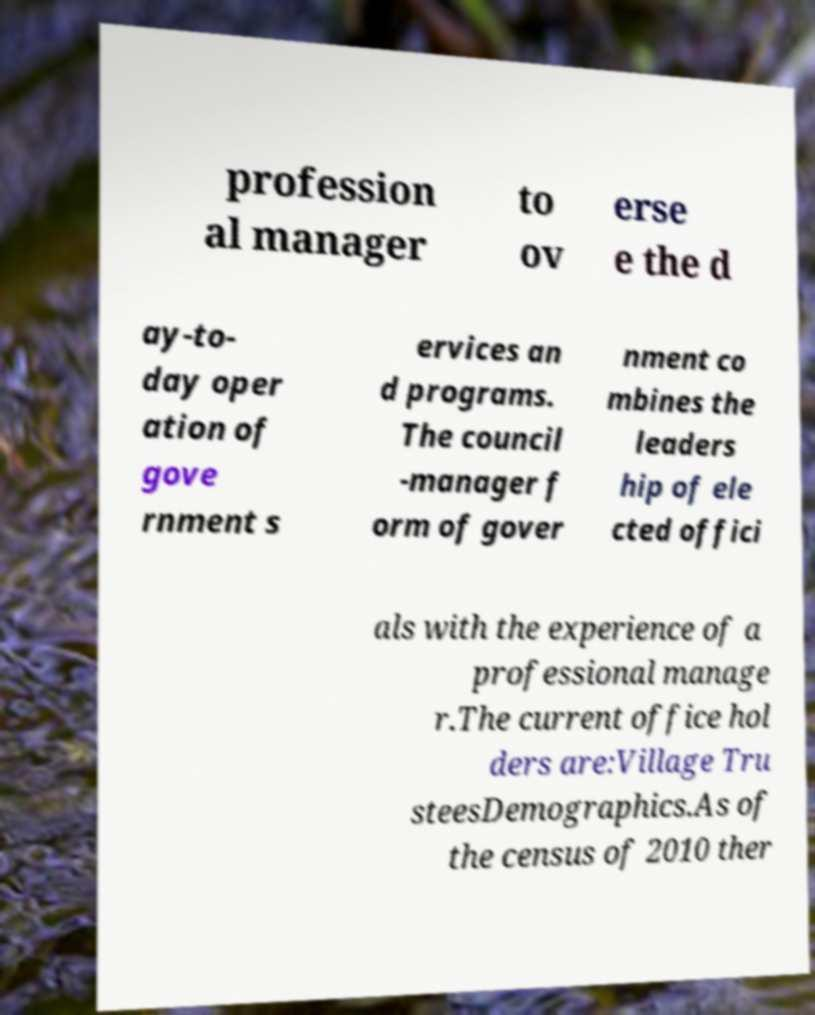Can you accurately transcribe the text from the provided image for me? profession al manager to ov erse e the d ay-to- day oper ation of gove rnment s ervices an d programs. The council -manager f orm of gover nment co mbines the leaders hip of ele cted offici als with the experience of a professional manage r.The current office hol ders are:Village Tru steesDemographics.As of the census of 2010 ther 